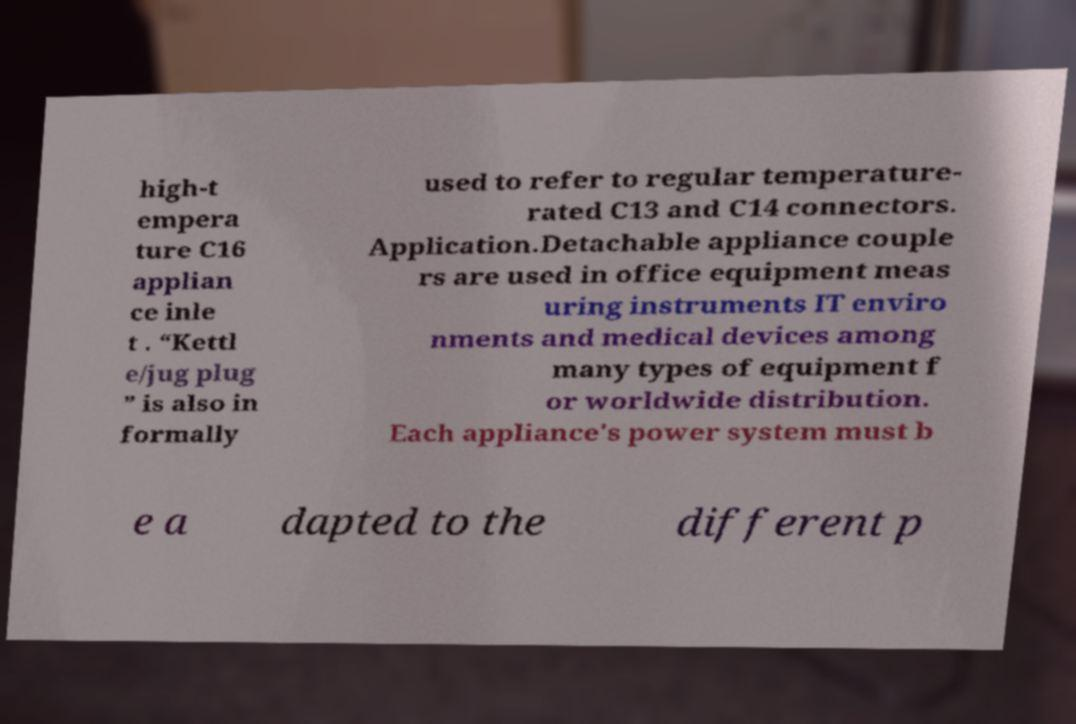Can you read and provide the text displayed in the image?This photo seems to have some interesting text. Can you extract and type it out for me? high-t empera ture C16 applian ce inle t . “Kettl e/jug plug ” is also in formally used to refer to regular temperature- rated C13 and C14 connectors. Application.Detachable appliance couple rs are used in office equipment meas uring instruments IT enviro nments and medical devices among many types of equipment f or worldwide distribution. Each appliance's power system must b e a dapted to the different p 